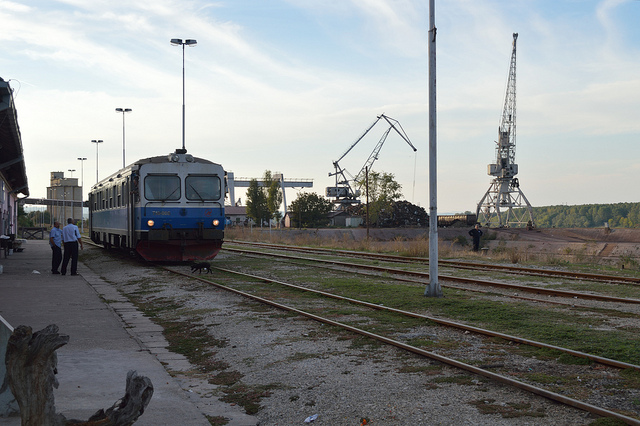<image>What letters are on the tower? There is no tower in the image. However, if there was it might contain the letters '0', 'USA', or 'ABC'. What letters are on the tower? There is no tower in the image, so there are no letters on the tower. 